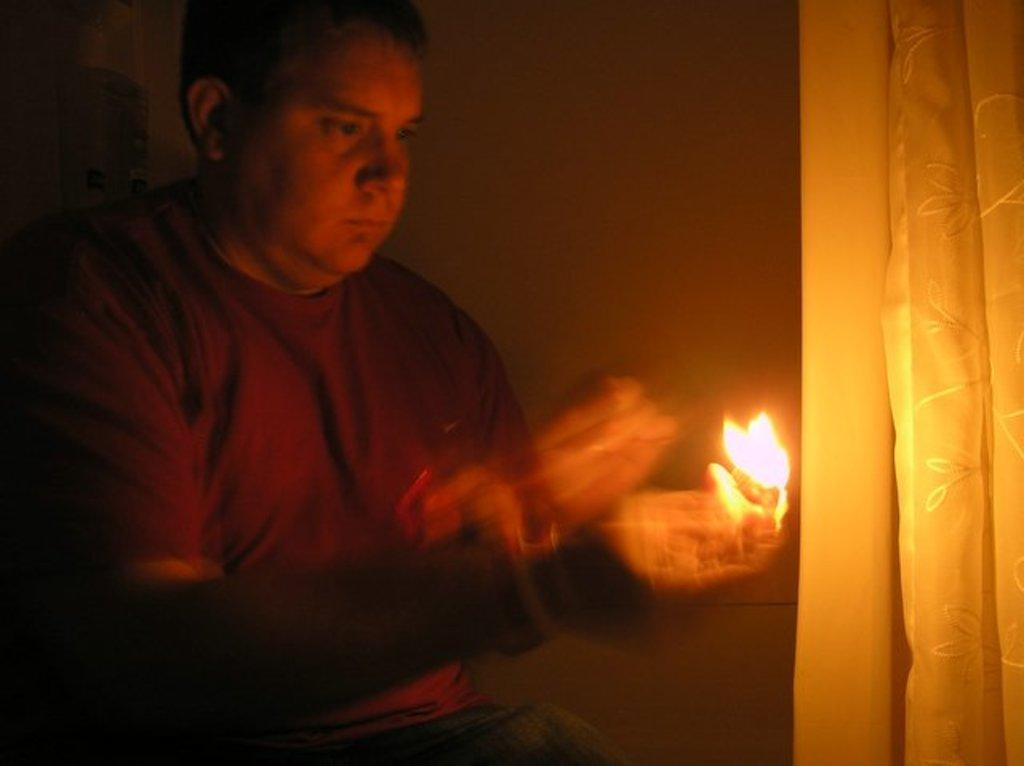Who or what is present in the image? There is a person in the image. What is the person holding? The person is holding a light. What can be seen on the right side of the image? There is a curtain on the right side of the image. What is visible in the background of the image? There is a wall visible in the background of the image. What type of soap is the person using to clean the wall in the image? There is no soap or cleaning activity present in the image; the person is holding a light. How many sheep are visible in the image? There are no sheep present in the image. 